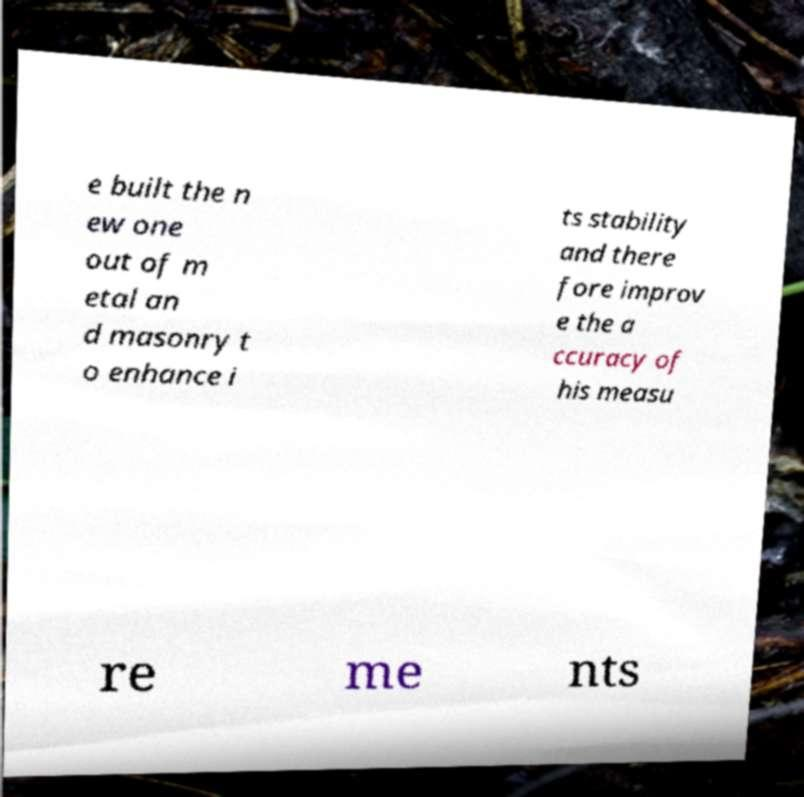There's text embedded in this image that I need extracted. Can you transcribe it verbatim? e built the n ew one out of m etal an d masonry t o enhance i ts stability and there fore improv e the a ccuracy of his measu re me nts 